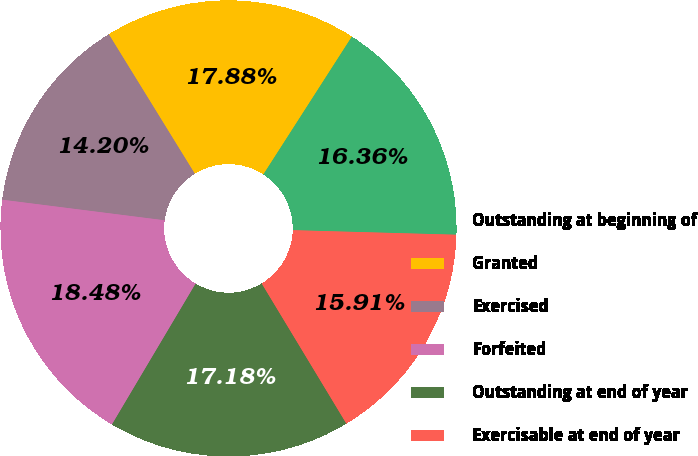<chart> <loc_0><loc_0><loc_500><loc_500><pie_chart><fcel>Outstanding at beginning of<fcel>Granted<fcel>Exercised<fcel>Forfeited<fcel>Outstanding at end of year<fcel>Exercisable at end of year<nl><fcel>16.36%<fcel>17.88%<fcel>14.2%<fcel>18.48%<fcel>17.18%<fcel>15.91%<nl></chart> 